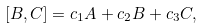Convert formula to latex. <formula><loc_0><loc_0><loc_500><loc_500>[ B , C ] = c _ { 1 } A + c _ { 2 } B + c _ { 3 } C ,</formula> 